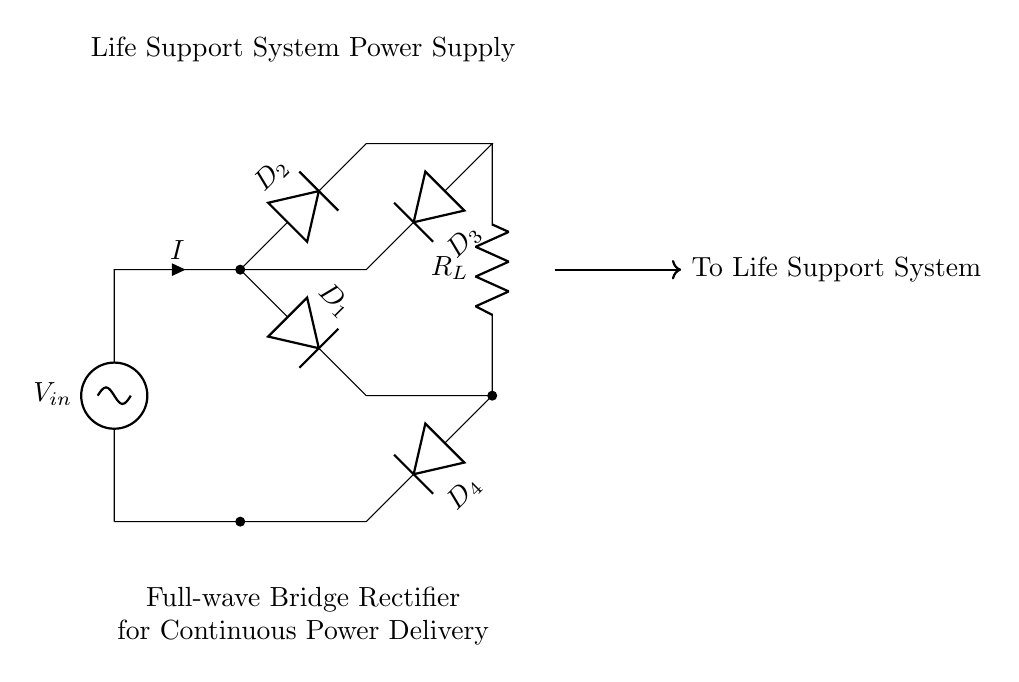What type of rectifier is shown in the circuit? The circuit diagram depicts a full-wave bridge rectifier, which is characteristic of having four diodes arranged in a bridge configuration to convert both halves of the input AC signal to DC.
Answer: Full-wave bridge rectifier How many diodes are present in the circuit? There are four diodes labeled D1, D2, D3, and D4 in the circuit, all contributing to the rectification process by allowing current to flow in only one direction.
Answer: Four What is the purpose of the resistor labeled R_L? The resistor R_L represents the load resistance in the circuit, where the converted DC power is delivered to the life support system, providing the needed current for operation.
Answer: Load resistance What happens to the current during one complete cycle of input voltage? In a complete cycle of input voltage, both halves of the AC waveform are used to generate a continuous DC output due to the arrangement of the diodes, ensuring current flows through the load during both phases.
Answer: Continuous DC output Which component limits the current direction? The diodes D1, D2, D3, and D4 are the components that limit the current direction, allowing it to flow in one direction only and thereby blocking reverse current.
Answer: Diodes How is the output voltage affected by the number of diodes? The output voltage is reduced by the forward voltage drop of two diodes in the path of current flow for each half-cycle, which can typically result in a voltage loss of about 1.4 volts for standard silicon diodes in total.
Answer: Reduced by approximately 1.4 volts What connects the output to the life support system? The thick arrow labeled "To Life Support System" connects the output of the rectifier to the life support system, indicating the direction of the delivered converted power.
Answer: Output connection 